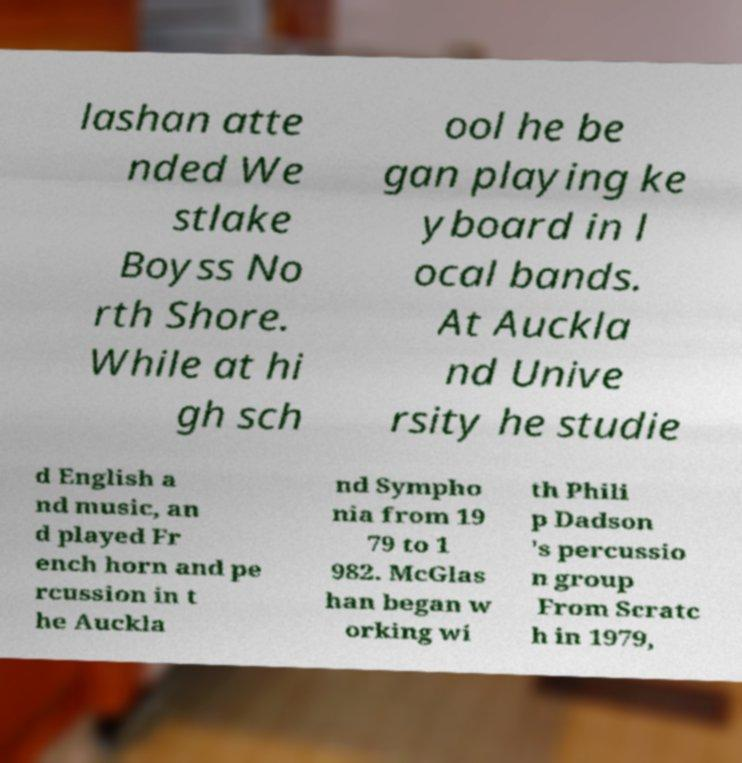Please identify and transcribe the text found in this image. lashan atte nded We stlake Boyss No rth Shore. While at hi gh sch ool he be gan playing ke yboard in l ocal bands. At Auckla nd Unive rsity he studie d English a nd music, an d played Fr ench horn and pe rcussion in t he Auckla nd Sympho nia from 19 79 to 1 982. McGlas han began w orking wi th Phili p Dadson 's percussio n group From Scratc h in 1979, 